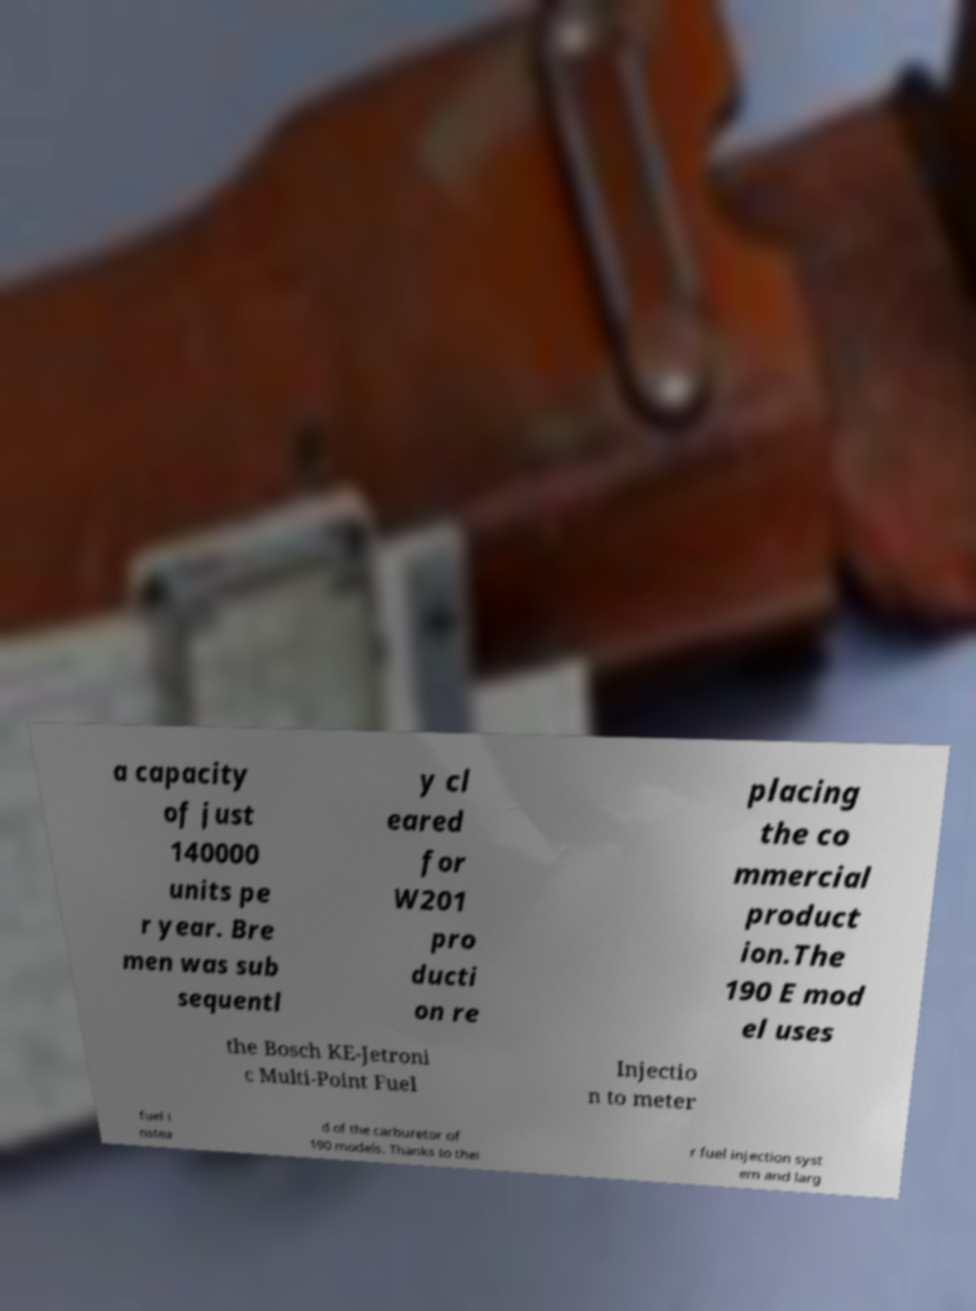Please read and relay the text visible in this image. What does it say? a capacity of just 140000 units pe r year. Bre men was sub sequentl y cl eared for W201 pro ducti on re placing the co mmercial product ion.The 190 E mod el uses the Bosch KE-Jetroni c Multi-Point Fuel Injectio n to meter fuel i nstea d of the carburetor of 190 models. Thanks to thei r fuel injection syst em and larg 